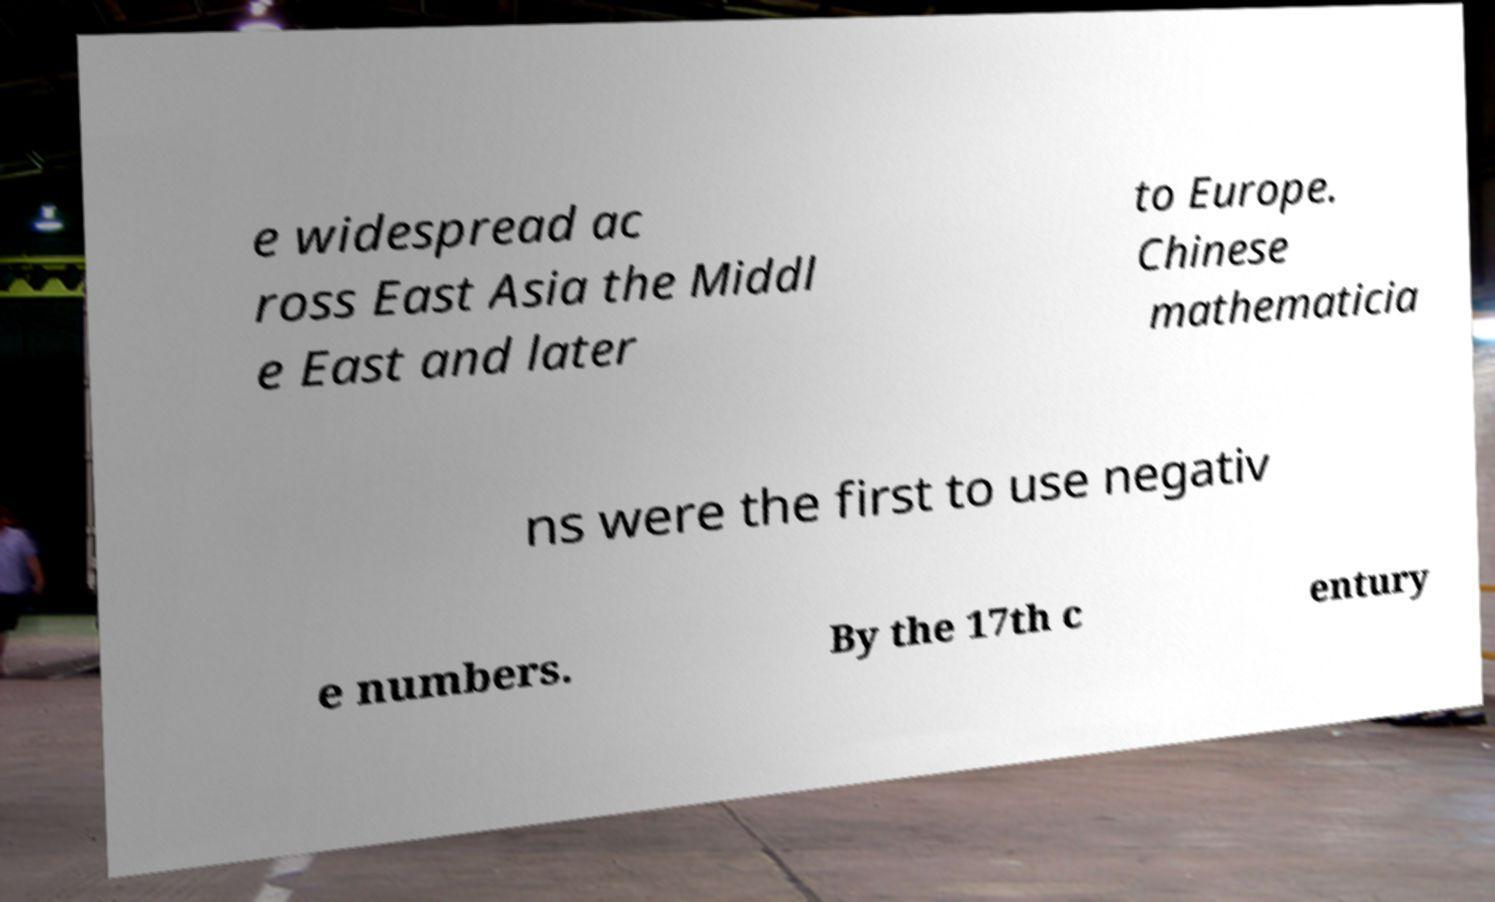Please read and relay the text visible in this image. What does it say? e widespread ac ross East Asia the Middl e East and later to Europe. Chinese mathematicia ns were the first to use negativ e numbers. By the 17th c entury 